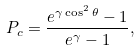Convert formula to latex. <formula><loc_0><loc_0><loc_500><loc_500>P _ { c } = \frac { e ^ { \gamma \cos ^ { 2 } \theta } - 1 } { e ^ { \gamma } - 1 } ,</formula> 